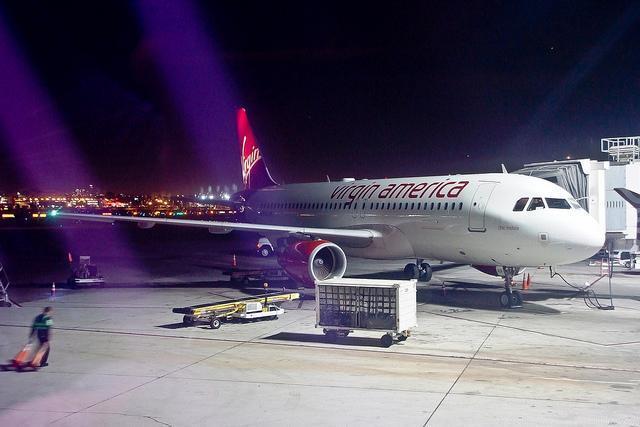How many beds are there?
Give a very brief answer. 0. 